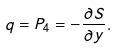Convert formula to latex. <formula><loc_0><loc_0><loc_500><loc_500>q = P _ { 4 } = - \frac { \partial S } { \partial y } .</formula> 